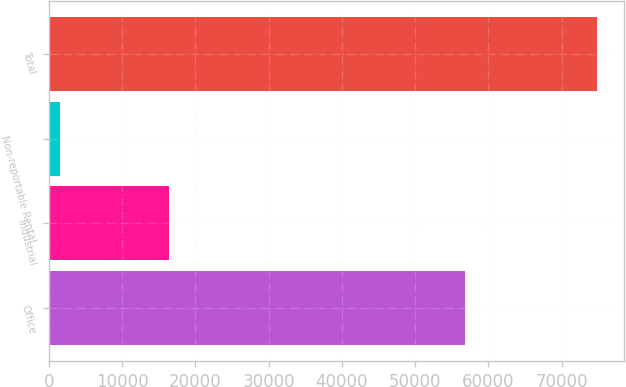<chart> <loc_0><loc_0><loc_500><loc_500><bar_chart><fcel>Office<fcel>Industrial<fcel>Non-reportable Rental<fcel>Total<nl><fcel>56844<fcel>16443<fcel>1527<fcel>74814<nl></chart> 